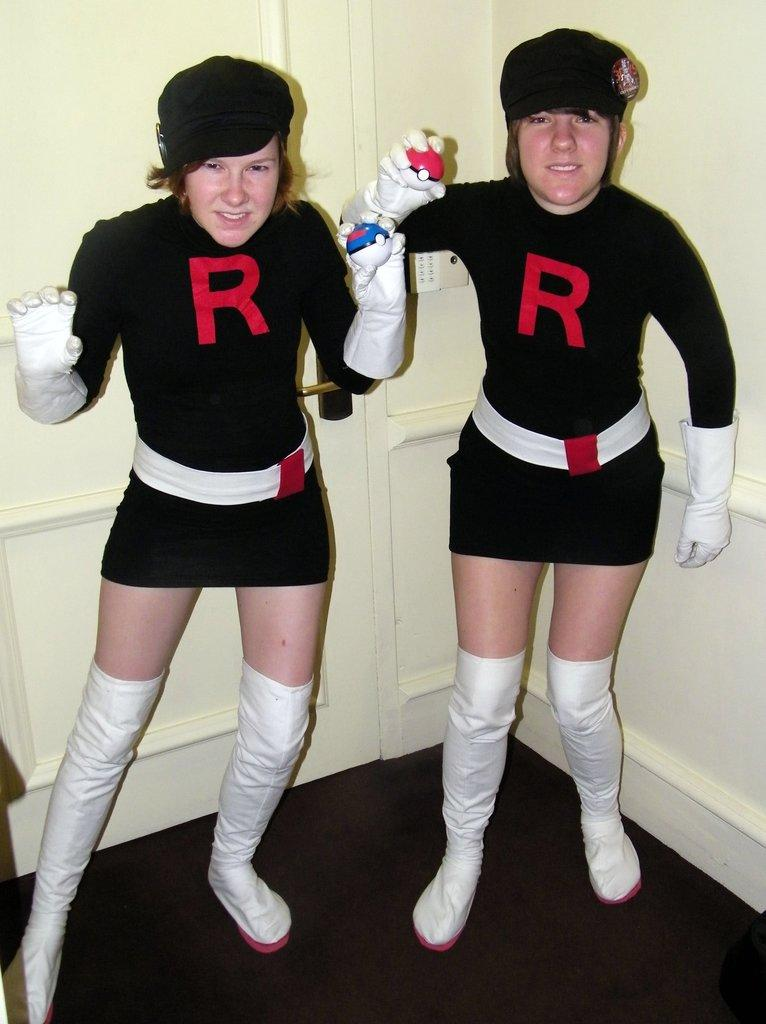<image>
Create a compact narrative representing the image presented. 2 girls pose in black dresses with a red R on them while holding pokemon balls. 